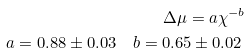<formula> <loc_0><loc_0><loc_500><loc_500>\Delta \mu = a \chi ^ { - b } \\ a = 0 . 8 8 \pm 0 . 0 3 \quad b = 0 . 6 5 \pm 0 . 0 2 \</formula> 